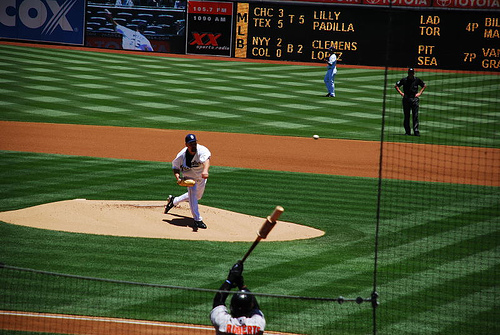Who conducts baseball league?
A. iit
B. tts
C. nht
D. mlb
Answer with the option's letter from the given choices directly. The entity that conducts professional baseball leagues in the United States is Major League Baseball (MLB), which corresponds to option D. MLB oversees the sport's major professional competitions, including the regular season games and the annual postseason World Series. 